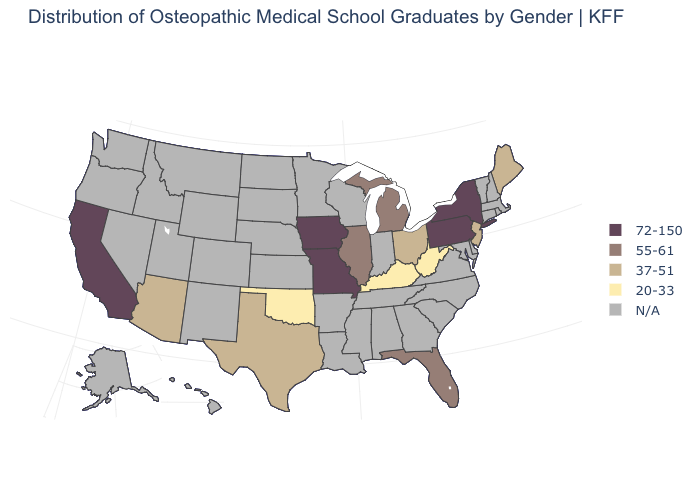What is the highest value in the MidWest ?
Give a very brief answer. 72-150. Is the legend a continuous bar?
Keep it brief. No. Among the states that border Massachusetts , which have the lowest value?
Give a very brief answer. New York. Does Maine have the lowest value in the USA?
Short answer required. No. Does Kentucky have the lowest value in the USA?
Concise answer only. Yes. Name the states that have a value in the range 72-150?
Short answer required. California, Iowa, Missouri, New York, Pennsylvania. What is the highest value in the USA?
Write a very short answer. 72-150. Name the states that have a value in the range 72-150?
Short answer required. California, Iowa, Missouri, New York, Pennsylvania. Name the states that have a value in the range 55-61?
Be succinct. Florida, Illinois, Michigan. What is the value of Virginia?
Be succinct. N/A. Which states have the lowest value in the USA?
Be succinct. Kentucky, Oklahoma, West Virginia. What is the lowest value in states that border Oregon?
Write a very short answer. 72-150. Which states hav the highest value in the MidWest?
Short answer required. Iowa, Missouri. Among the states that border West Virginia , does Ohio have the lowest value?
Give a very brief answer. No. What is the value of Alabama?
Keep it brief. N/A. 